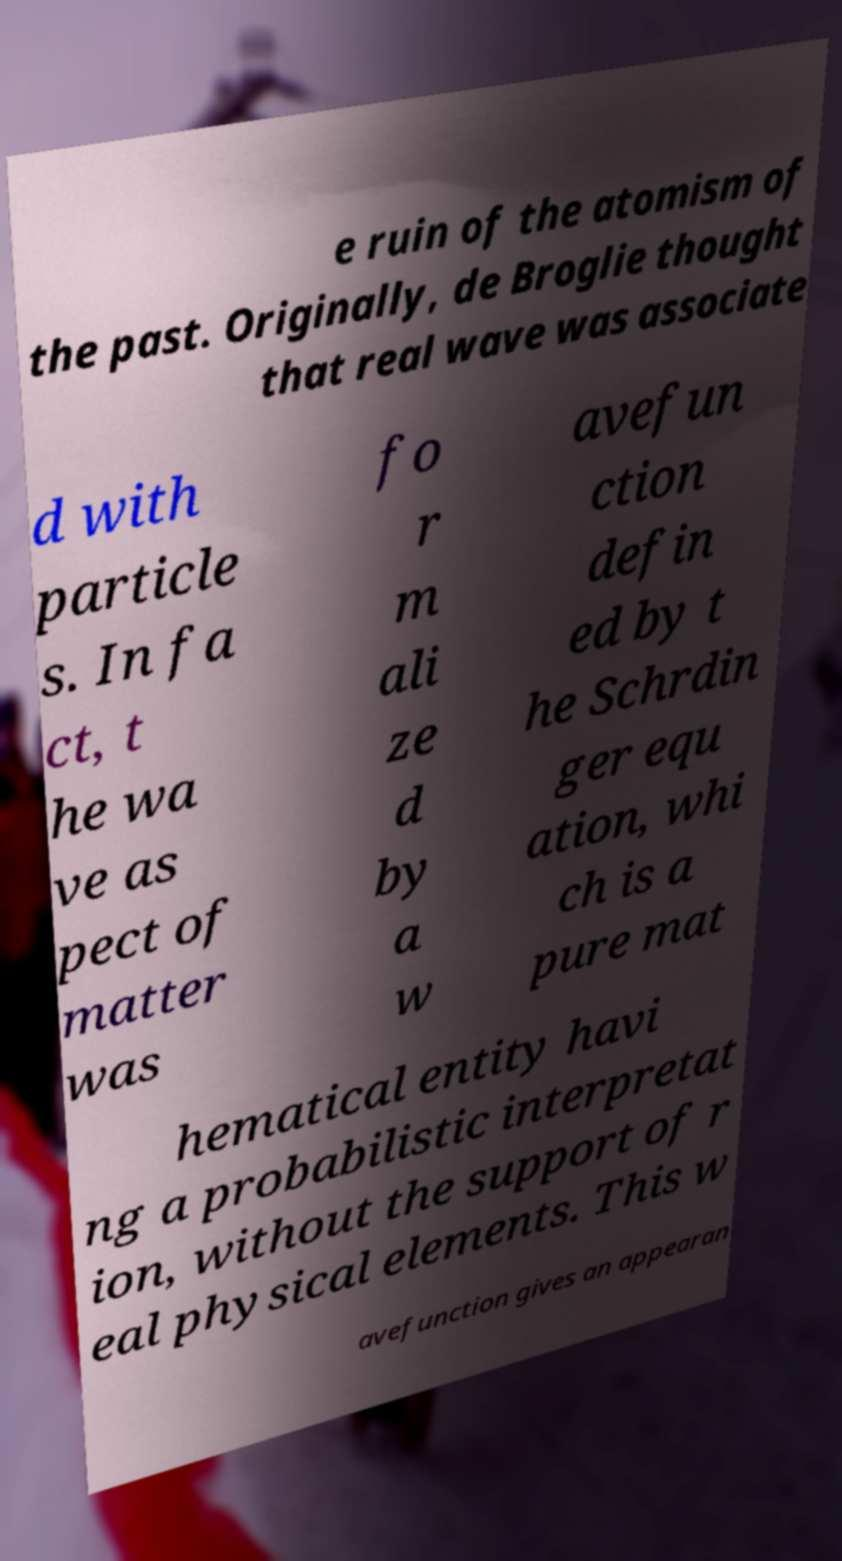I need the written content from this picture converted into text. Can you do that? e ruin of the atomism of the past. Originally, de Broglie thought that real wave was associate d with particle s. In fa ct, t he wa ve as pect of matter was fo r m ali ze d by a w avefun ction defin ed by t he Schrdin ger equ ation, whi ch is a pure mat hematical entity havi ng a probabilistic interpretat ion, without the support of r eal physical elements. This w avefunction gives an appearan 